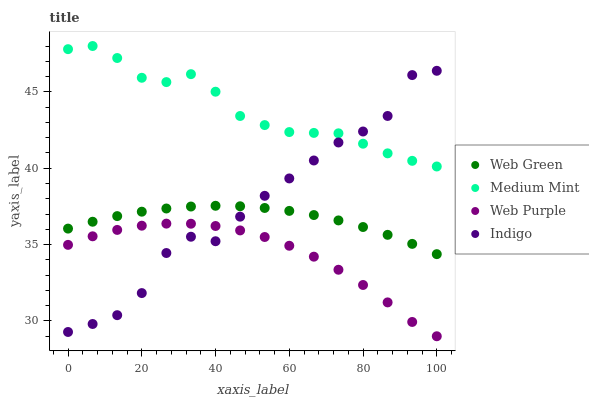Does Web Purple have the minimum area under the curve?
Answer yes or no. Yes. Does Medium Mint have the maximum area under the curve?
Answer yes or no. Yes. Does Indigo have the minimum area under the curve?
Answer yes or no. No. Does Indigo have the maximum area under the curve?
Answer yes or no. No. Is Web Green the smoothest?
Answer yes or no. Yes. Is Indigo the roughest?
Answer yes or no. Yes. Is Web Purple the smoothest?
Answer yes or no. No. Is Web Purple the roughest?
Answer yes or no. No. Does Web Purple have the lowest value?
Answer yes or no. Yes. Does Indigo have the lowest value?
Answer yes or no. No. Does Medium Mint have the highest value?
Answer yes or no. Yes. Does Indigo have the highest value?
Answer yes or no. No. Is Web Green less than Medium Mint?
Answer yes or no. Yes. Is Medium Mint greater than Web Purple?
Answer yes or no. Yes. Does Web Purple intersect Indigo?
Answer yes or no. Yes. Is Web Purple less than Indigo?
Answer yes or no. No. Is Web Purple greater than Indigo?
Answer yes or no. No. Does Web Green intersect Medium Mint?
Answer yes or no. No. 